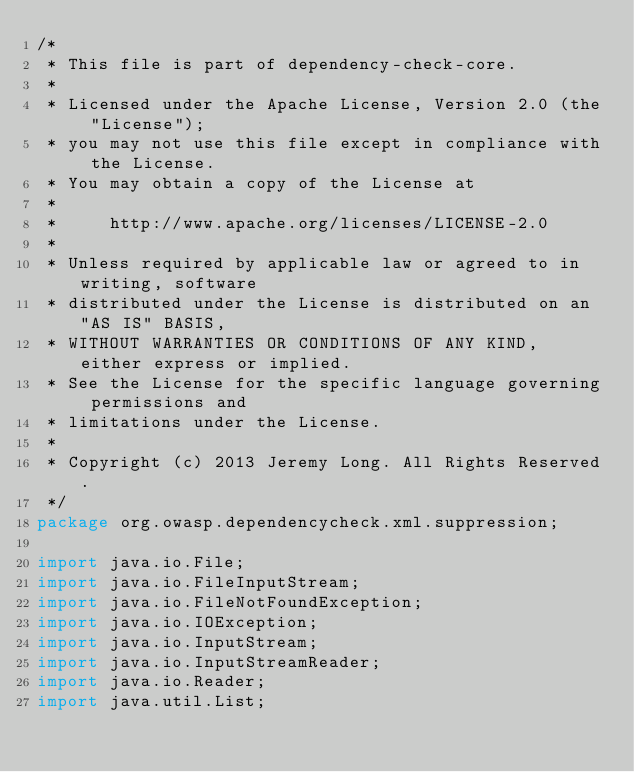<code> <loc_0><loc_0><loc_500><loc_500><_Java_>/*
 * This file is part of dependency-check-core.
 *
 * Licensed under the Apache License, Version 2.0 (the "License");
 * you may not use this file except in compliance with the License.
 * You may obtain a copy of the License at
 *
 *     http://www.apache.org/licenses/LICENSE-2.0
 *
 * Unless required by applicable law or agreed to in writing, software
 * distributed under the License is distributed on an "AS IS" BASIS,
 * WITHOUT WARRANTIES OR CONDITIONS OF ANY KIND, either express or implied.
 * See the License for the specific language governing permissions and
 * limitations under the License.
 *
 * Copyright (c) 2013 Jeremy Long. All Rights Reserved.
 */
package org.owasp.dependencycheck.xml.suppression;

import java.io.File;
import java.io.FileInputStream;
import java.io.FileNotFoundException;
import java.io.IOException;
import java.io.InputStream;
import java.io.InputStreamReader;
import java.io.Reader;
import java.util.List;</code> 